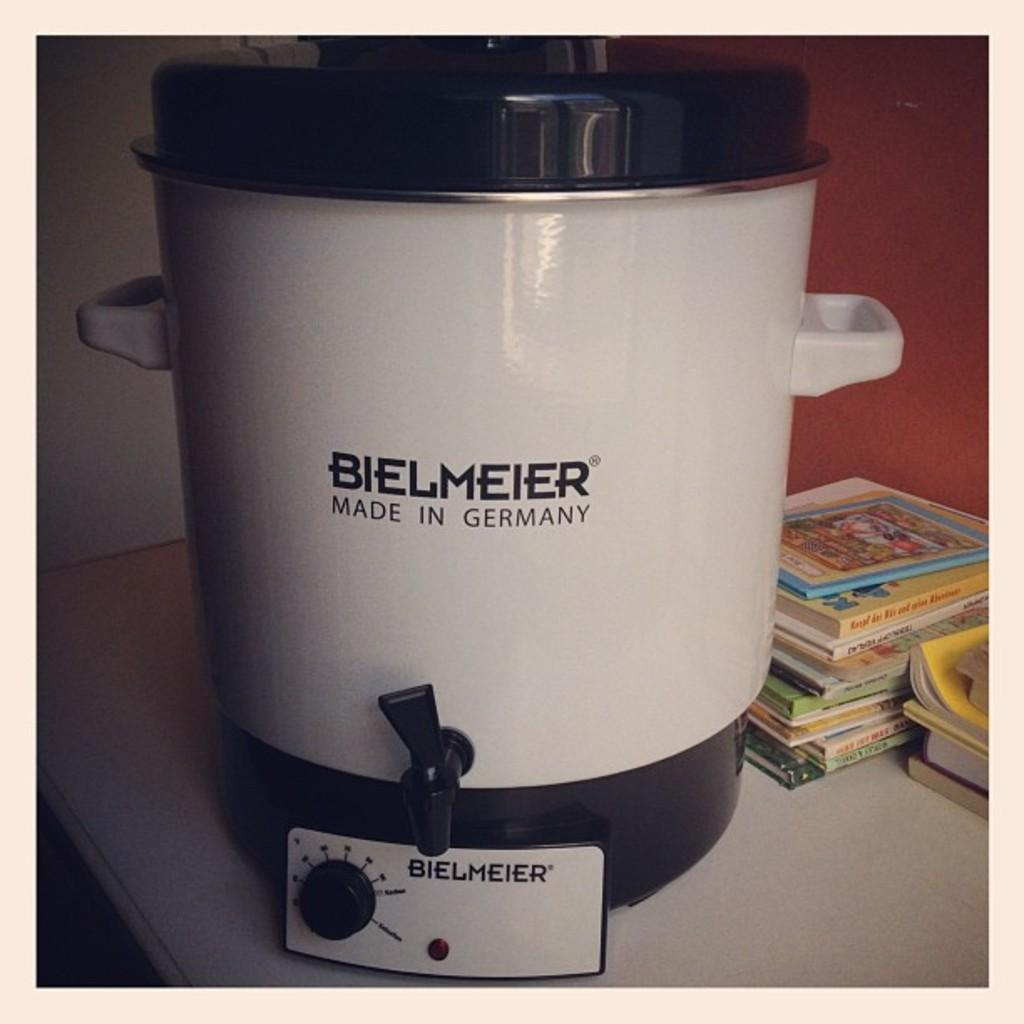Provide a one-sentence caption for the provided image. A stack of books a crockpot by Bielmier. 